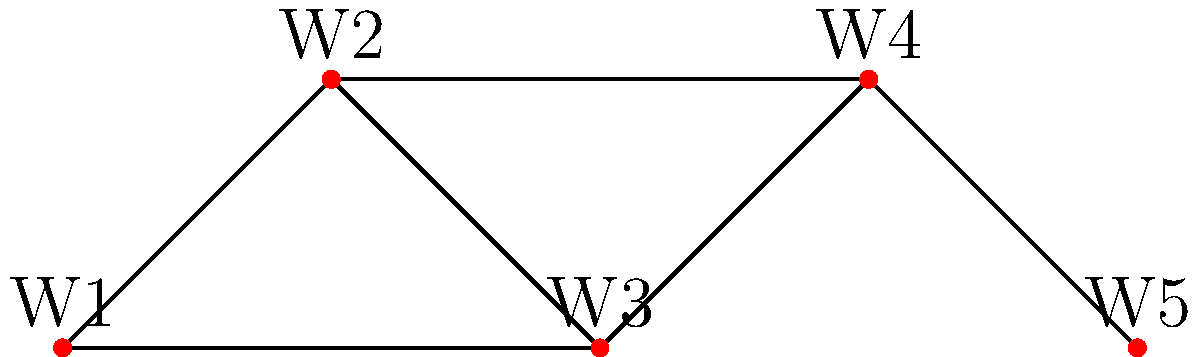In a network graph representing writer collaborations, five writers (W1 to W5) are connected as shown above. What is the minimum number of collaborations that need to be removed to disconnect W1 from W5? To solve this problem, we need to analyze the graph and find the minimum number of edges (collaborations) that, when removed, will disconnect W1 from W5. Let's approach this step-by-step:

1. Identify all possible paths from W1 to W5:
   a. W1 - W2 - W3 - W4 - W5
   b. W1 - W3 - W4 - W5

2. Observe that both paths share the edge W3 - W4.

3. If we remove the edge W3 - W4, it will disconnect W1 from W5 because:
   a. The path W1 - W2 - W3 - W4 - W5 is broken
   b. The path W1 - W3 - W4 - W5 is also broken

4. There is no way to disconnect W1 from W5 by removing fewer than one edge.

Therefore, the minimum number of collaborations that need to be removed to disconnect W1 from W5 is 1.
Answer: 1 